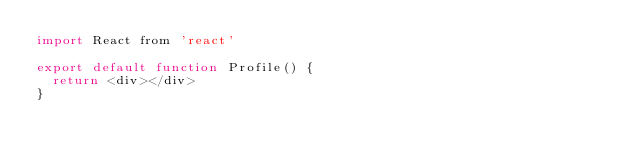<code> <loc_0><loc_0><loc_500><loc_500><_JavaScript_>import React from 'react'

export default function Profile() {
  return <div></div>
}
</code> 